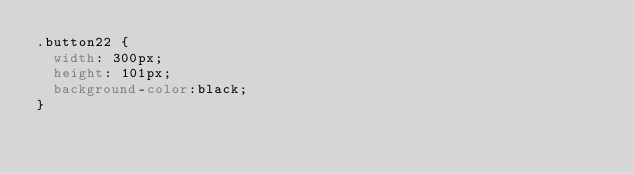Convert code to text. <code><loc_0><loc_0><loc_500><loc_500><_CSS_>.button22 {
  width: 300px;
  height: 101px;
  background-color:black;
}</code> 